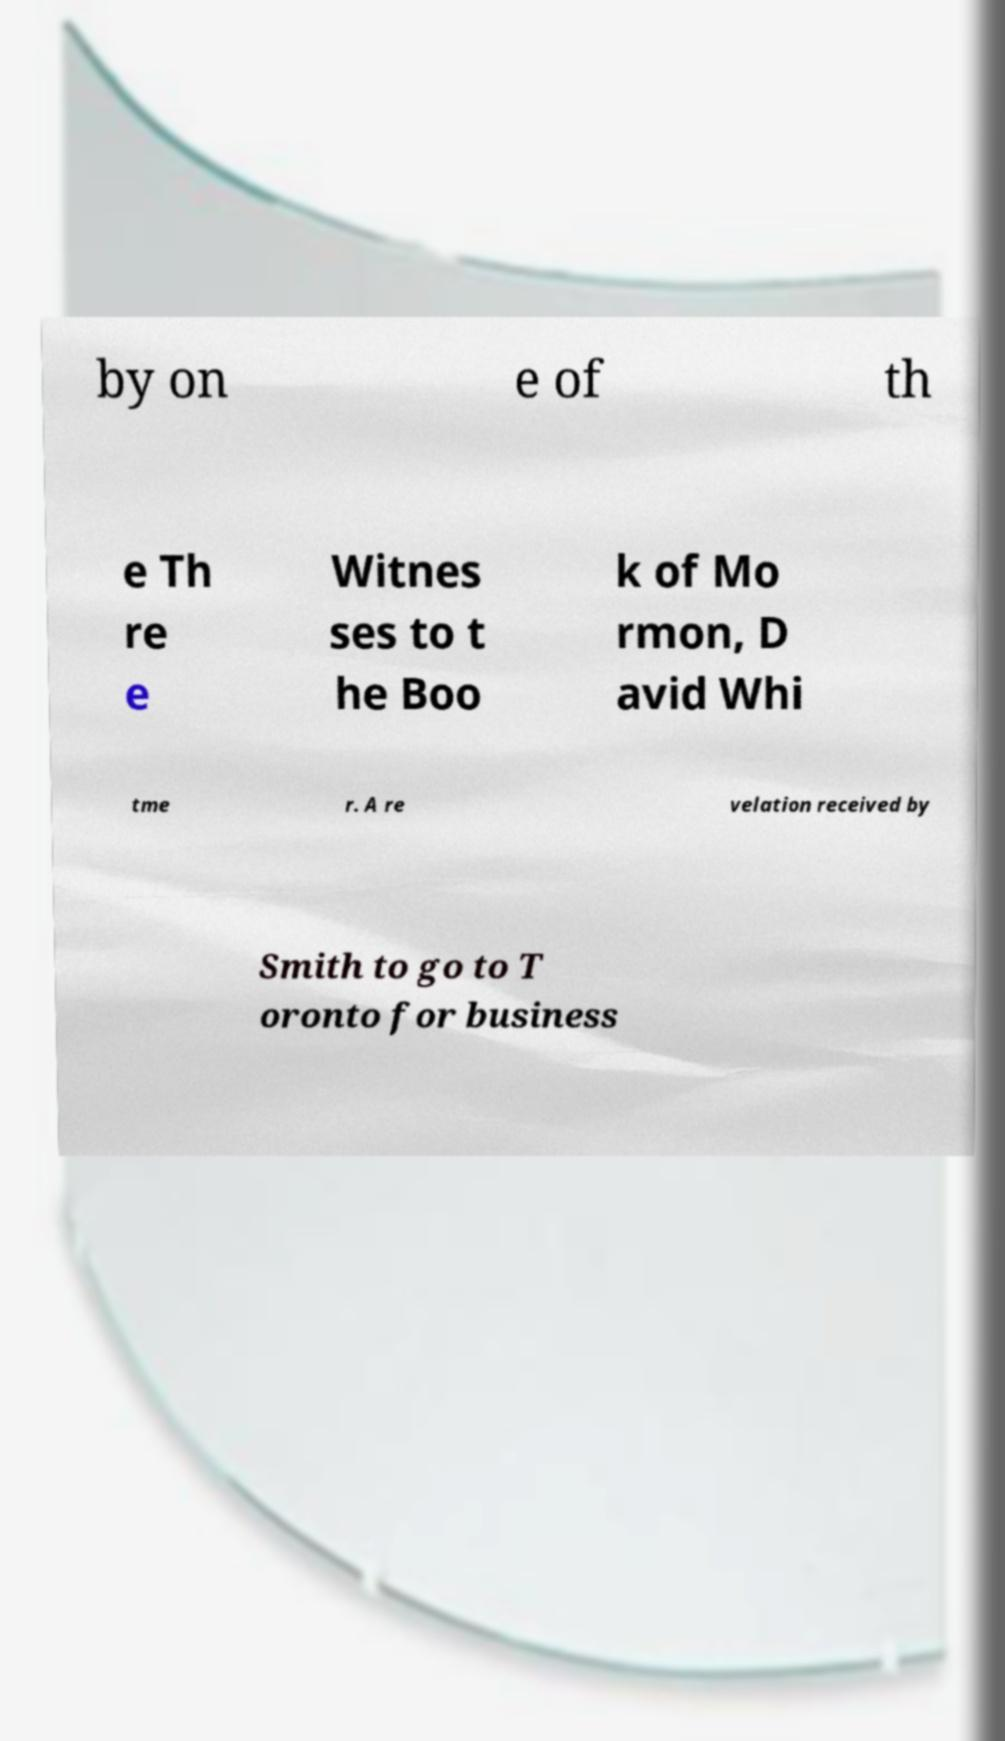Could you extract and type out the text from this image? by on e of th e Th re e Witnes ses to t he Boo k of Mo rmon, D avid Whi tme r. A re velation received by Smith to go to T oronto for business 